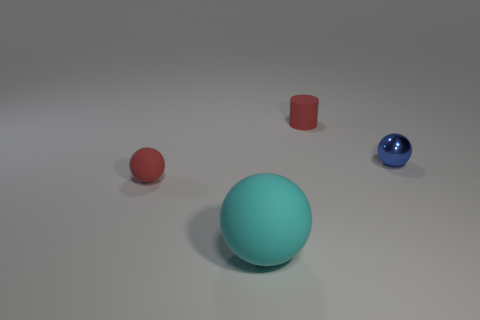Are there any other things that are the same size as the cyan thing?
Offer a very short reply. No. Do the cyan object and the red cylinder have the same material?
Make the answer very short. Yes. The tiny object that is in front of the small sphere that is right of the red rubber object behind the blue object is what color?
Your answer should be compact. Red. The blue thing is what shape?
Give a very brief answer. Sphere. Is the color of the small shiny sphere the same as the small thing that is in front of the tiny blue metallic sphere?
Your response must be concise. No. Are there an equal number of red things behind the cyan matte thing and red things?
Keep it short and to the point. Yes. How many cyan matte things are the same size as the blue shiny object?
Your answer should be very brief. 0. What is the shape of the rubber thing that is the same color as the tiny rubber sphere?
Offer a terse response. Cylinder. Are there any tiny blue cylinders?
Give a very brief answer. No. Is the shape of the small object that is left of the big cyan matte thing the same as the blue metal thing behind the large cyan sphere?
Provide a succinct answer. Yes. 